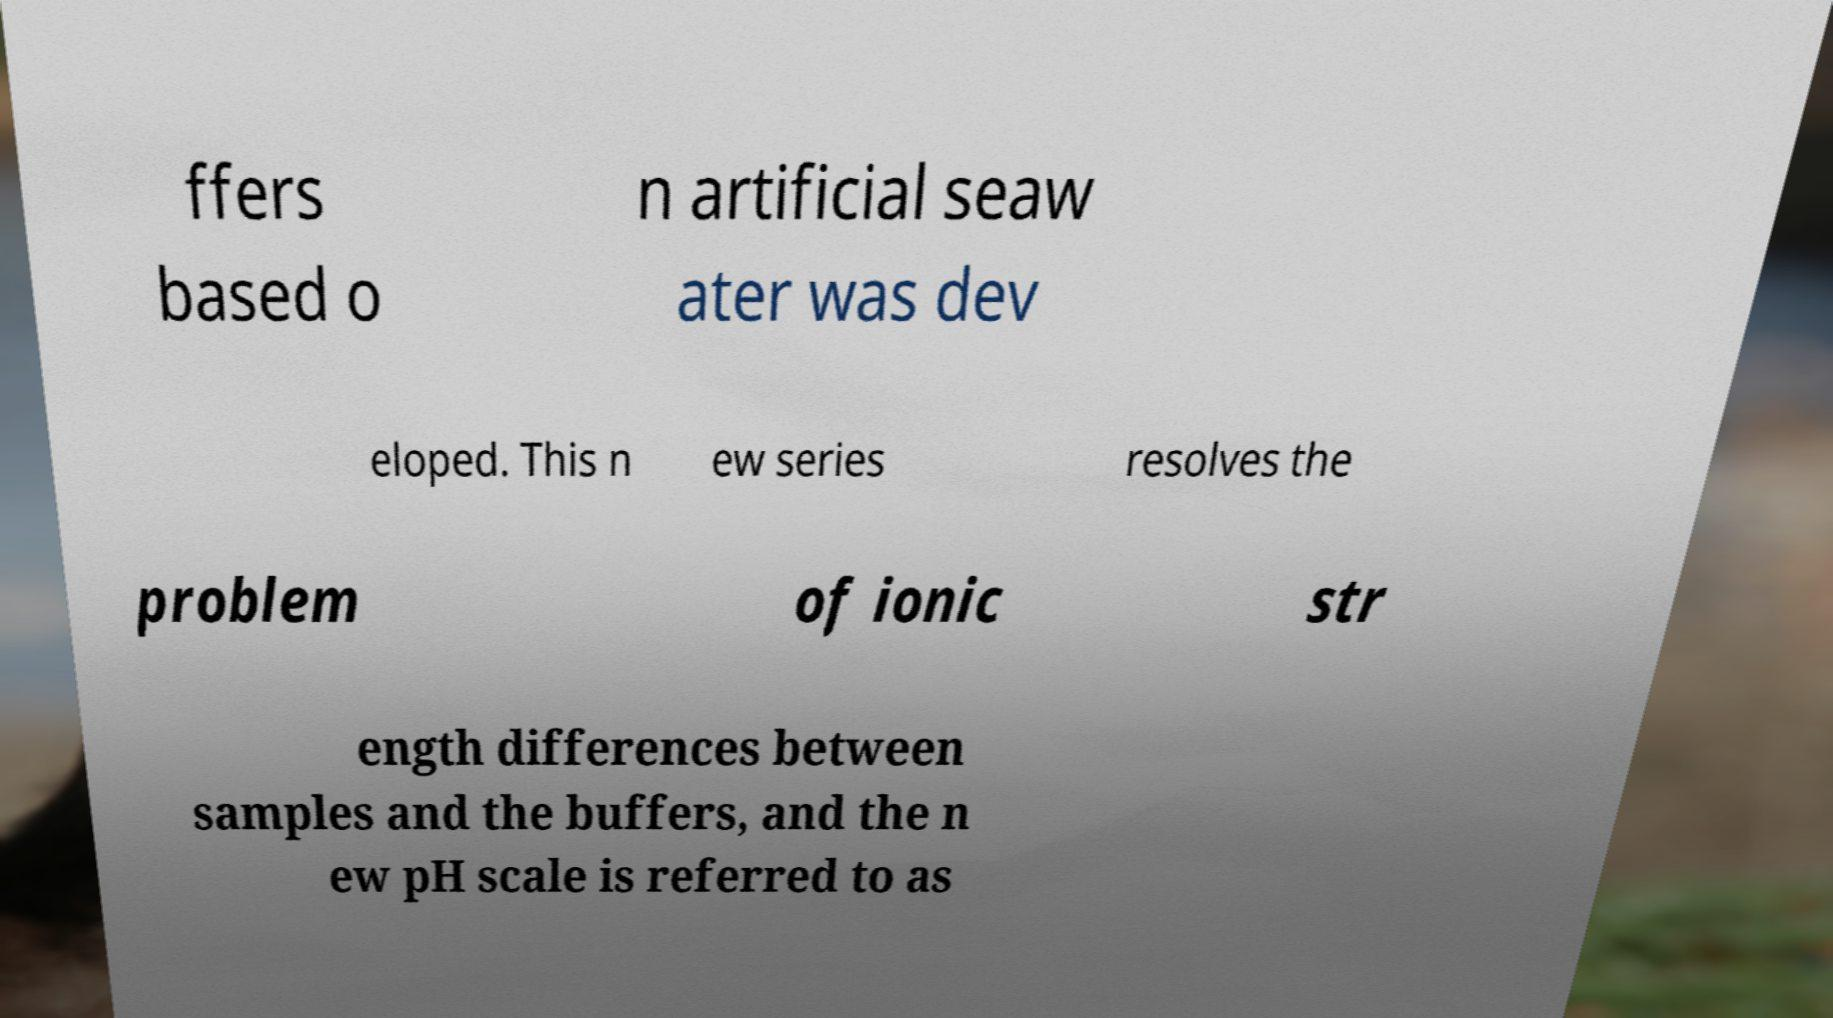Please identify and transcribe the text found in this image. ffers based o n artificial seaw ater was dev eloped. This n ew series resolves the problem of ionic str ength differences between samples and the buffers, and the n ew pH scale is referred to as 